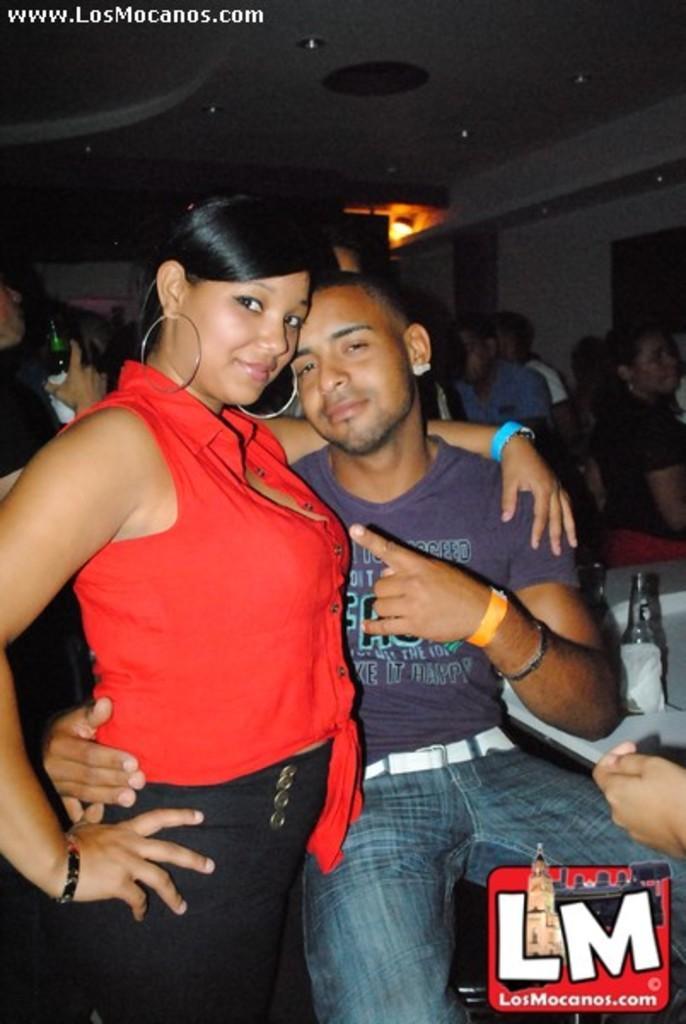Please provide a concise description of this image. In the foreground of this image, there is a woman standing beside a man sitting. In the background, we can see persons and a person holding bottle, a person´s hand on the right and two bottles on the white surface. On the top, there is the ceiling and a light. 